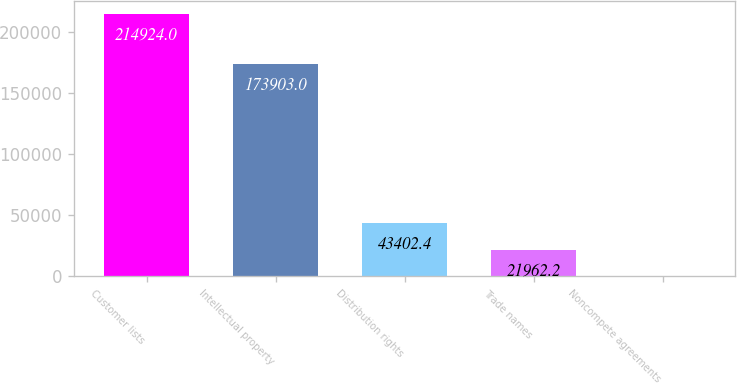Convert chart to OTSL. <chart><loc_0><loc_0><loc_500><loc_500><bar_chart><fcel>Customer lists<fcel>Intellectual property<fcel>Distribution rights<fcel>Trade names<fcel>Noncompete agreements<nl><fcel>214924<fcel>173903<fcel>43402.4<fcel>21962.2<fcel>522<nl></chart> 